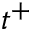<formula> <loc_0><loc_0><loc_500><loc_500>t ^ { + }</formula> 